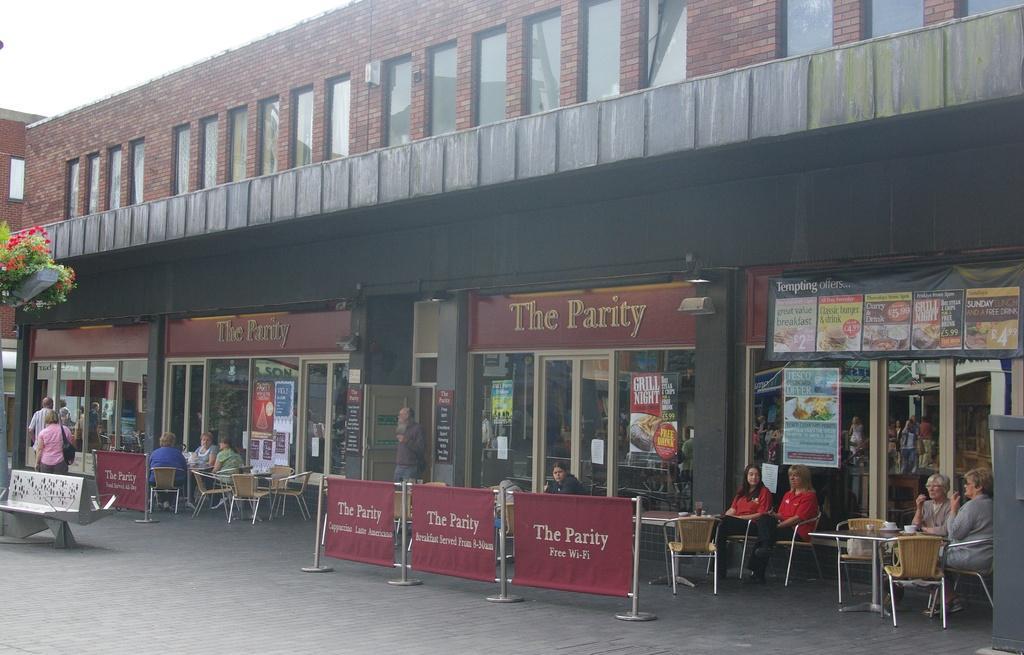In one or two sentences, can you explain what this image depicts? In this picture, we can see building with glass doors, we can see some stores, we can see the posters, grounds and some objects on the ground like poles, posters, tables, chairs, and we can see plants with flowers, and we can see a few people and the sky. 